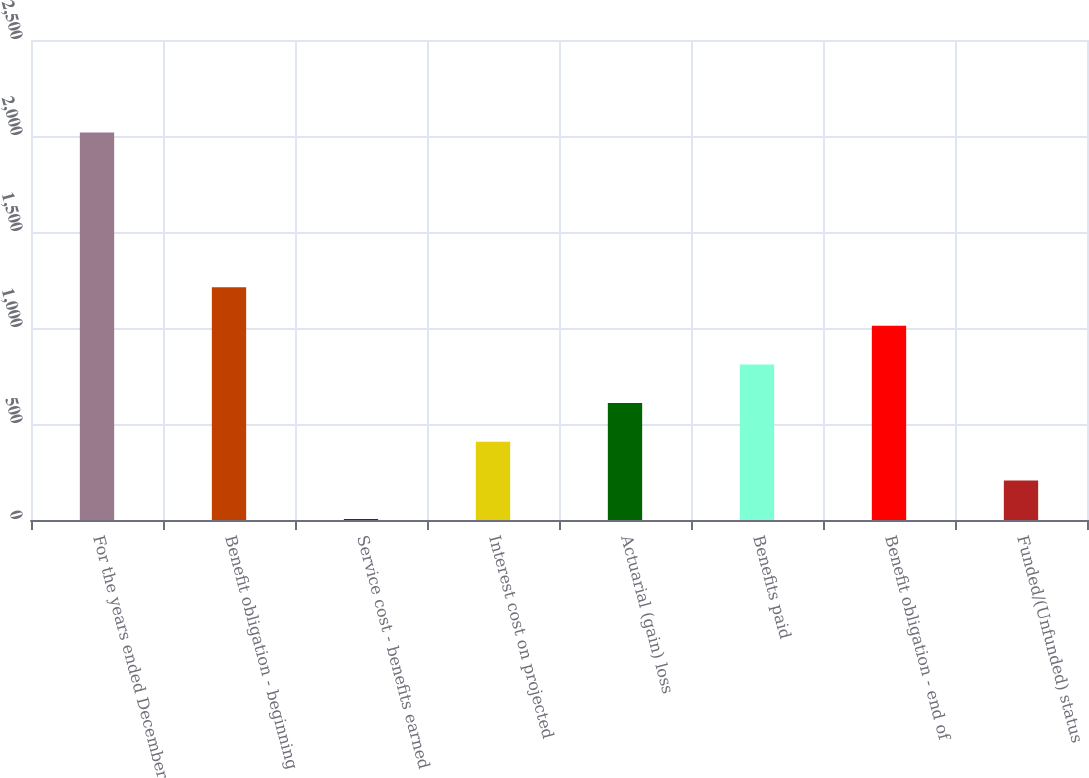<chart> <loc_0><loc_0><loc_500><loc_500><bar_chart><fcel>For the years ended December<fcel>Benefit obligation - beginning<fcel>Service cost - benefits earned<fcel>Interest cost on projected<fcel>Actuarial (gain) loss<fcel>Benefits paid<fcel>Benefit obligation - end of<fcel>Funded/(Unfunded) status<nl><fcel>2018<fcel>1212.8<fcel>5<fcel>407.6<fcel>608.9<fcel>810.2<fcel>1011.5<fcel>206.3<nl></chart> 